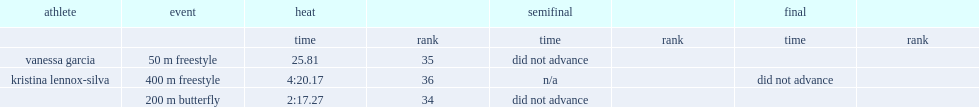What was the result that vanessa garcia got in the 50 m freestyle event in the heat? 25.81. 